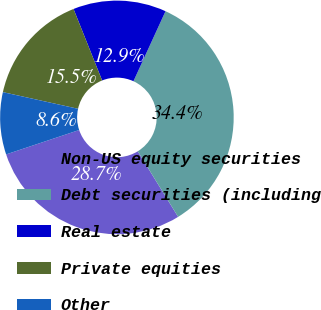Convert chart. <chart><loc_0><loc_0><loc_500><loc_500><pie_chart><fcel>Non-US equity securities<fcel>Debt securities (including<fcel>Real estate<fcel>Private equities<fcel>Other<nl><fcel>28.65%<fcel>34.38%<fcel>12.89%<fcel>15.47%<fcel>8.6%<nl></chart> 